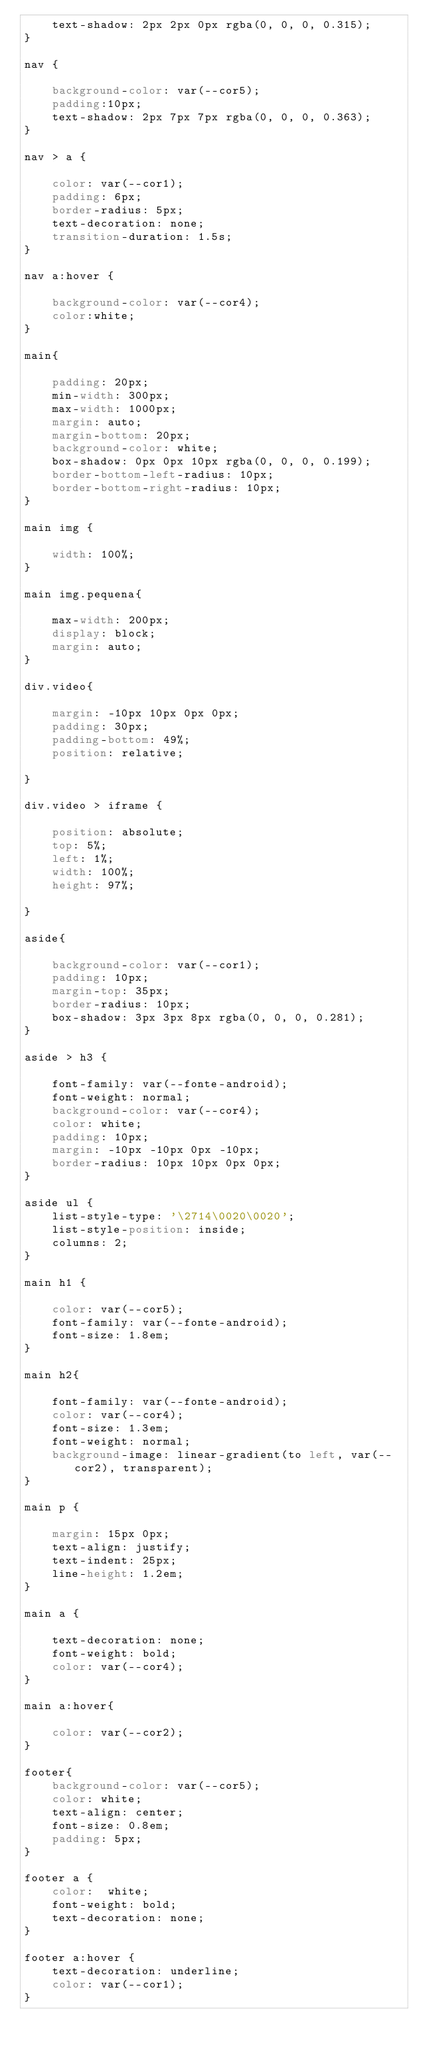<code> <loc_0><loc_0><loc_500><loc_500><_CSS_>    text-shadow: 2px 2px 0px rgba(0, 0, 0, 0.315);
}

nav {

    background-color: var(--cor5);
    padding:10px;
    text-shadow: 2px 7px 7px rgba(0, 0, 0, 0.363);
}

nav > a {

    color: var(--cor1);
    padding: 6px;
    border-radius: 5px;
    text-decoration: none;
    transition-duration: 1.5s;
}

nav a:hover {

    background-color: var(--cor4);
    color:white;
}

main{

    padding: 20px;  
    min-width: 300px;
    max-width: 1000px;
    margin: auto;
    margin-bottom: 20px;
    background-color: white;
    box-shadow: 0px 0px 10px rgba(0, 0, 0, 0.199);
    border-bottom-left-radius: 10px;
    border-bottom-right-radius: 10px;
}

main img {

    width: 100%;
}

main img.pequena{

    max-width: 200px;
    display: block;
    margin: auto;
}

div.video{ 

    margin: -10px 10px 0px 0px;
    padding: 30px;
    padding-bottom: 49%;
    position: relative;

}

div.video > iframe {
    
    position: absolute;
    top: 5%;
    left: 1%;
    width: 100%;
    height: 97%;

}

aside{

    background-color: var(--cor1);
    padding: 10px;
    margin-top: 35px;
    border-radius: 10px;
    box-shadow: 3px 3px 8px rgba(0, 0, 0, 0.281);
}

aside > h3 {

    font-family: var(--fonte-android);
    font-weight: normal;
    background-color: var(--cor4);
    color: white;
    padding: 10px;
    margin: -10px -10px 0px -10px;
    border-radius: 10px 10px 0px 0px;
}

aside ul {
    list-style-type: '\2714\0020\0020';
    list-style-position: inside;
    columns: 2;
}

main h1 {

    color: var(--cor5);
    font-family: var(--fonte-android);
    font-size: 1.8em;
}

main h2{

    font-family: var(--fonte-android);
    color: var(--cor4);
    font-size: 1.3em;
    font-weight: normal;
    background-image: linear-gradient(to left, var(--cor2), transparent);
}

main p {

    margin: 15px 0px;
    text-align: justify;
    text-indent: 25px;
    line-height: 1.2em;
}

main a {

    text-decoration: none;
    font-weight: bold;
    color: var(--cor4);
}

main a:hover{

    color: var(--cor2);
}

footer{
    background-color: var(--cor5);
    color: white;
    text-align: center;
    font-size: 0.8em;
    padding: 5px;
}

footer a {
    color:  white;
    font-weight: bold;
    text-decoration: none;
}

footer a:hover {
    text-decoration: underline;
    color: var(--cor1);
}</code> 